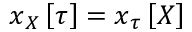<formula> <loc_0><loc_0><loc_500><loc_500>x _ { \ u { X } } \left [ \tau \right ] = x _ { \ u { \tau } } \left [ X \right ]</formula> 